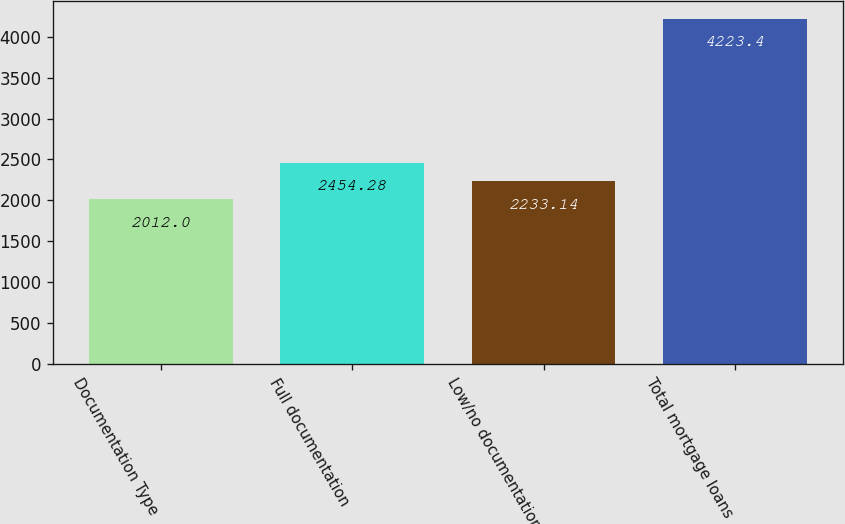<chart> <loc_0><loc_0><loc_500><loc_500><bar_chart><fcel>Documentation Type<fcel>Full documentation<fcel>Low/no documentation<fcel>Total mortgage loans<nl><fcel>2012<fcel>2454.28<fcel>2233.14<fcel>4223.4<nl></chart> 